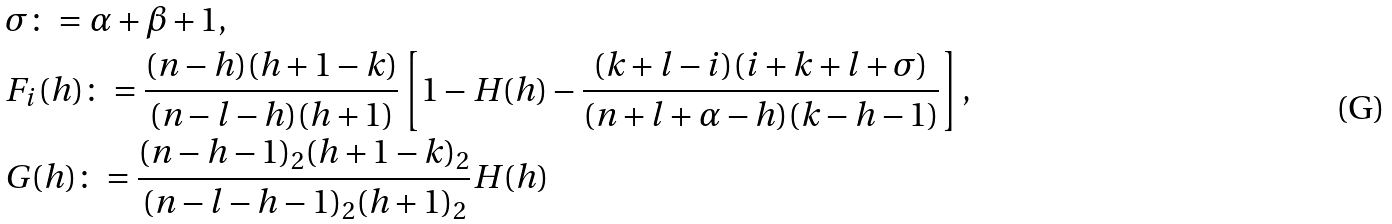<formula> <loc_0><loc_0><loc_500><loc_500>& \sigma \colon = \alpha + \beta + 1 , \\ & F _ { i } ( h ) \colon = \frac { ( n - h ) ( h + 1 - k ) } { ( n - l - h ) ( h + 1 ) } \left [ 1 - H ( h ) - \frac { ( k + l - i ) ( i + k + l + \sigma ) } { ( n + l + \alpha - h ) ( k - h - 1 ) } \right ] , \\ & G ( h ) \colon = \frac { ( n - h - 1 ) _ { 2 } ( h + 1 - k ) _ { 2 } } { ( n - l - h - 1 ) _ { 2 } ( h + 1 ) _ { 2 } } H ( h )</formula> 